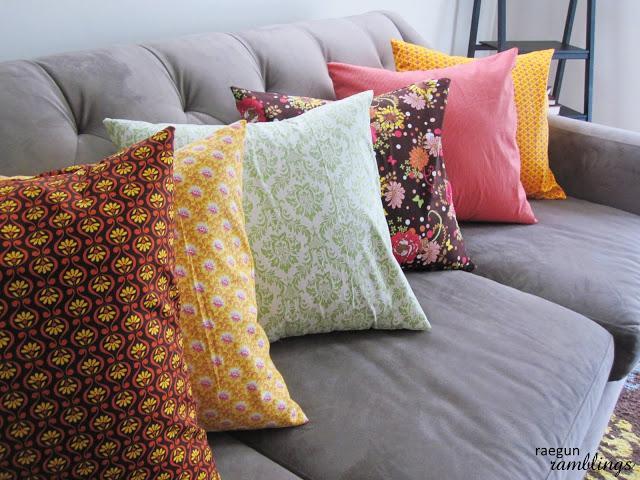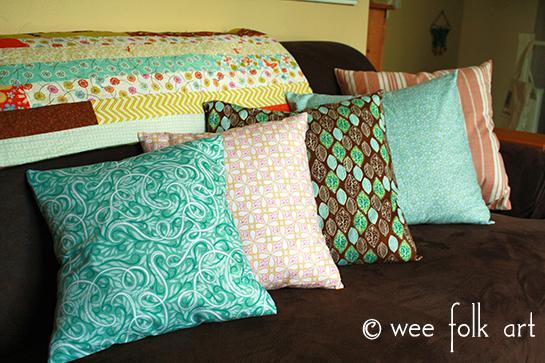The first image is the image on the left, the second image is the image on the right. Given the left and right images, does the statement "Each image shows at least three colorful throw pillows on a solid-colored sofa." hold true? Answer yes or no. Yes. The first image is the image on the left, the second image is the image on the right. Examine the images to the left and right. Is the description "Throw pillows are laid on a couch in each image." accurate? Answer yes or no. Yes. 